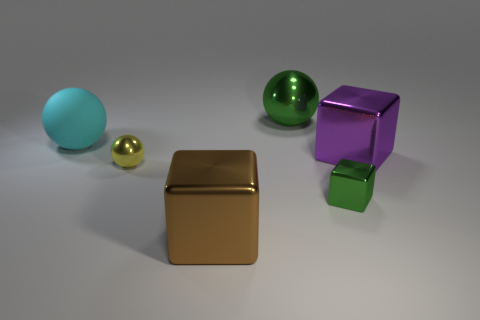Subtract all shiny balls. How many balls are left? 1 Subtract 1 spheres. How many spheres are left? 2 Add 4 small objects. How many small objects are left? 6 Add 5 big green matte blocks. How many big green matte blocks exist? 5 Add 4 red cylinders. How many objects exist? 10 Subtract all cyan spheres. How many spheres are left? 2 Subtract 0 cyan cylinders. How many objects are left? 6 Subtract all brown spheres. Subtract all green cubes. How many spheres are left? 3 Subtract all green cylinders. How many purple spheres are left? 0 Subtract all large purple rubber cylinders. Subtract all yellow metal balls. How many objects are left? 5 